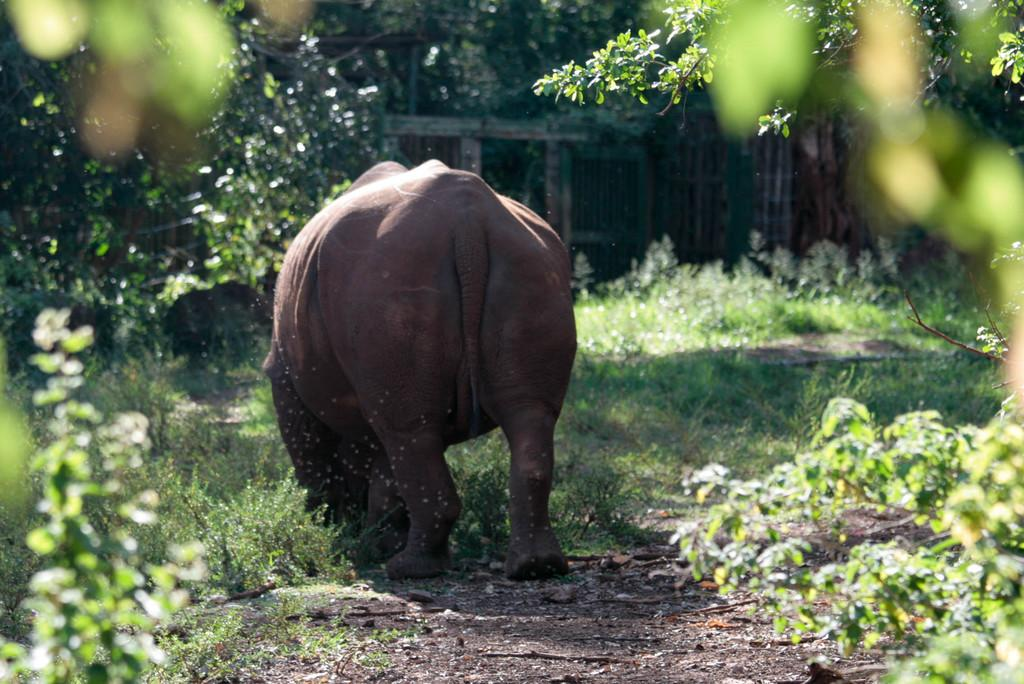What type of animal can be seen in the image? There is an animal standing on the ground in the image. What can be observed in terms of vegetation in the image? There are many plants and trees in the image. What architectural feature is present in the image? There is a wall in the image. What is used for cooking in the image? There is a grill in the image. What color of powder is being used by the animal in the image? There is no powder present in the image, and the animal is not using any. 